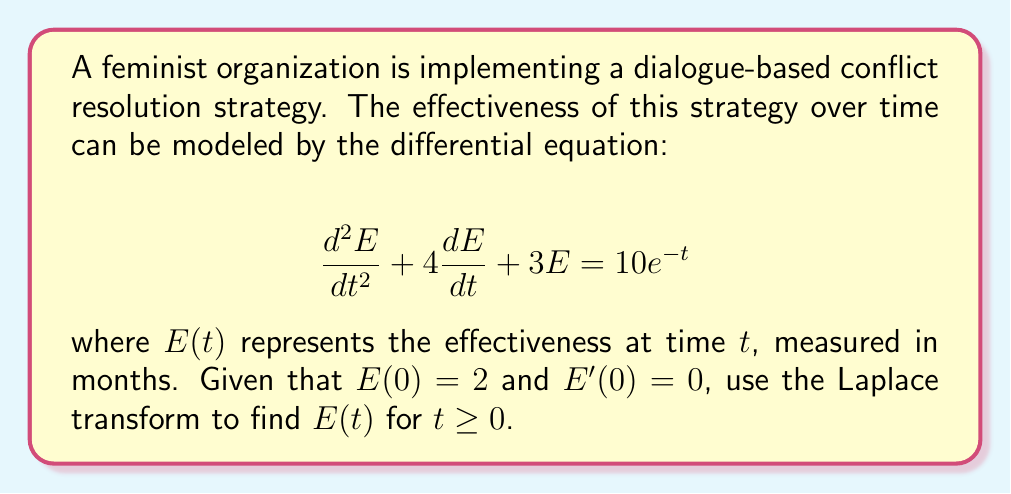Give your solution to this math problem. Let's solve this problem step by step using the Laplace transform:

1) First, let's take the Laplace transform of both sides of the equation. Let $\mathcal{L}\{E(t)\} = X(s)$.

   $$\mathcal{L}\{\frac{d^2E}{dt^2} + 4\frac{dE}{dt} + 3E\} = \mathcal{L}\{10e^{-t}\}$$

2) Using Laplace transform properties:

   $$s^2X(s) - sE(0) - E'(0) + 4[sX(s) - E(0)] + 3X(s) = \frac{10}{s+1}$$

3) Substituting the initial conditions $E(0) = 2$ and $E'(0) = 0$:

   $$s^2X(s) - 2s + 4sX(s) - 8 + 3X(s) = \frac{10}{s+1}$$

4) Simplify:

   $$(s^2 + 4s + 3)X(s) = \frac{10}{s+1} + 2s + 8$$

5) Solve for $X(s)$:

   $$X(s) = \frac{10}{(s+1)(s^2 + 4s + 3)} + \frac{2s + 8}{s^2 + 4s + 3}$$

6) Decompose into partial fractions:

   $$X(s) = \frac{A}{s+1} + \frac{B}{s+1} + \frac{C}{s+3} + \frac{2s + 8}{s^2 + 4s + 3}$$

   where $A = 5/2$, $B = -5/2$, and $C = 5/2$

7) Take the inverse Laplace transform:

   $$E(t) = \frac{5}{2}e^{-t} - \frac{5}{2}e^{-t} + \frac{5}{2}e^{-3t} + 2e^{-t} - 2e^{-3t}$$

8) Simplify:

   $$E(t) = 2e^{-t} + \frac{1}{2}e^{-3t}$$

This is the solution for $E(t)$ for $t \geq 0$.
Answer: $E(t) = 2e^{-t} + \frac{1}{2}e^{-3t}$ for $t \geq 0$ 